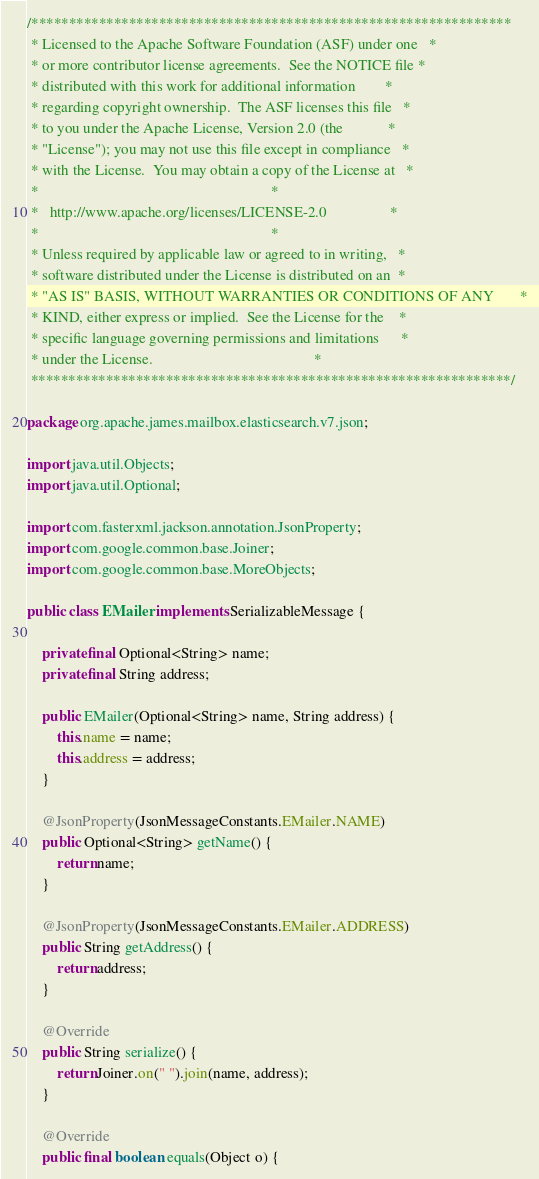<code> <loc_0><loc_0><loc_500><loc_500><_Java_>/****************************************************************
 * Licensed to the Apache Software Foundation (ASF) under one   *
 * or more contributor license agreements.  See the NOTICE file *
 * distributed with this work for additional information        *
 * regarding copyright ownership.  The ASF licenses this file   *
 * to you under the Apache License, Version 2.0 (the            *
 * "License"); you may not use this file except in compliance   *
 * with the License.  You may obtain a copy of the License at   *
 *                                                              *
 *   http://www.apache.org/licenses/LICENSE-2.0                 *
 *                                                              *
 * Unless required by applicable law or agreed to in writing,   *
 * software distributed under the License is distributed on an  *
 * "AS IS" BASIS, WITHOUT WARRANTIES OR CONDITIONS OF ANY       *
 * KIND, either express or implied.  See the License for the    *
 * specific language governing permissions and limitations      *
 * under the License.                                           *
 ****************************************************************/

package org.apache.james.mailbox.elasticsearch.v7.json;

import java.util.Objects;
import java.util.Optional;

import com.fasterxml.jackson.annotation.JsonProperty;
import com.google.common.base.Joiner;
import com.google.common.base.MoreObjects;

public class EMailer implements SerializableMessage {

    private final Optional<String> name;
    private final String address;

    public EMailer(Optional<String> name, String address) {
        this.name = name;
        this.address = address;
    }

    @JsonProperty(JsonMessageConstants.EMailer.NAME)
    public Optional<String> getName() {
        return name;
    }

    @JsonProperty(JsonMessageConstants.EMailer.ADDRESS)
    public String getAddress() {
        return address;
    }

    @Override
    public String serialize() {
        return Joiner.on(" ").join(name, address);
    }

    @Override
    public final boolean equals(Object o) {</code> 